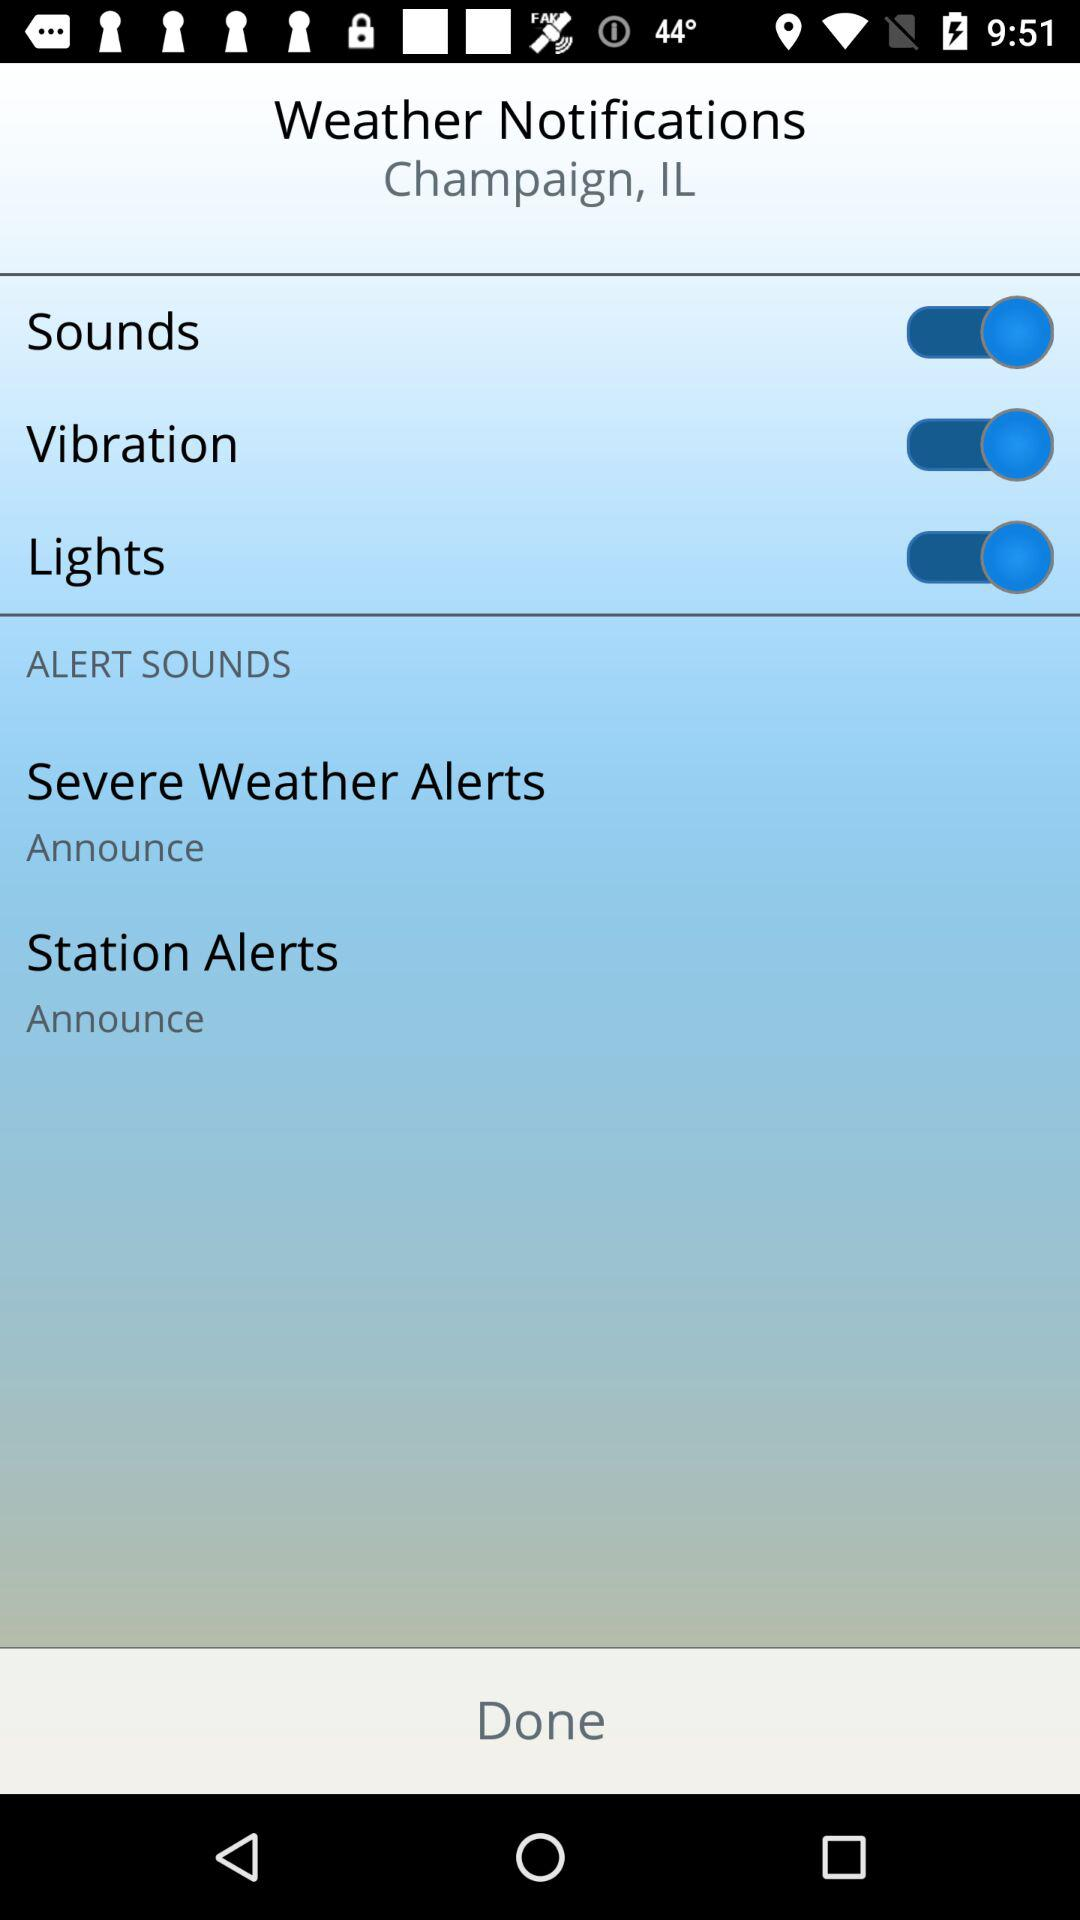How many alert sounds are there?
Answer the question using a single word or phrase. 2 